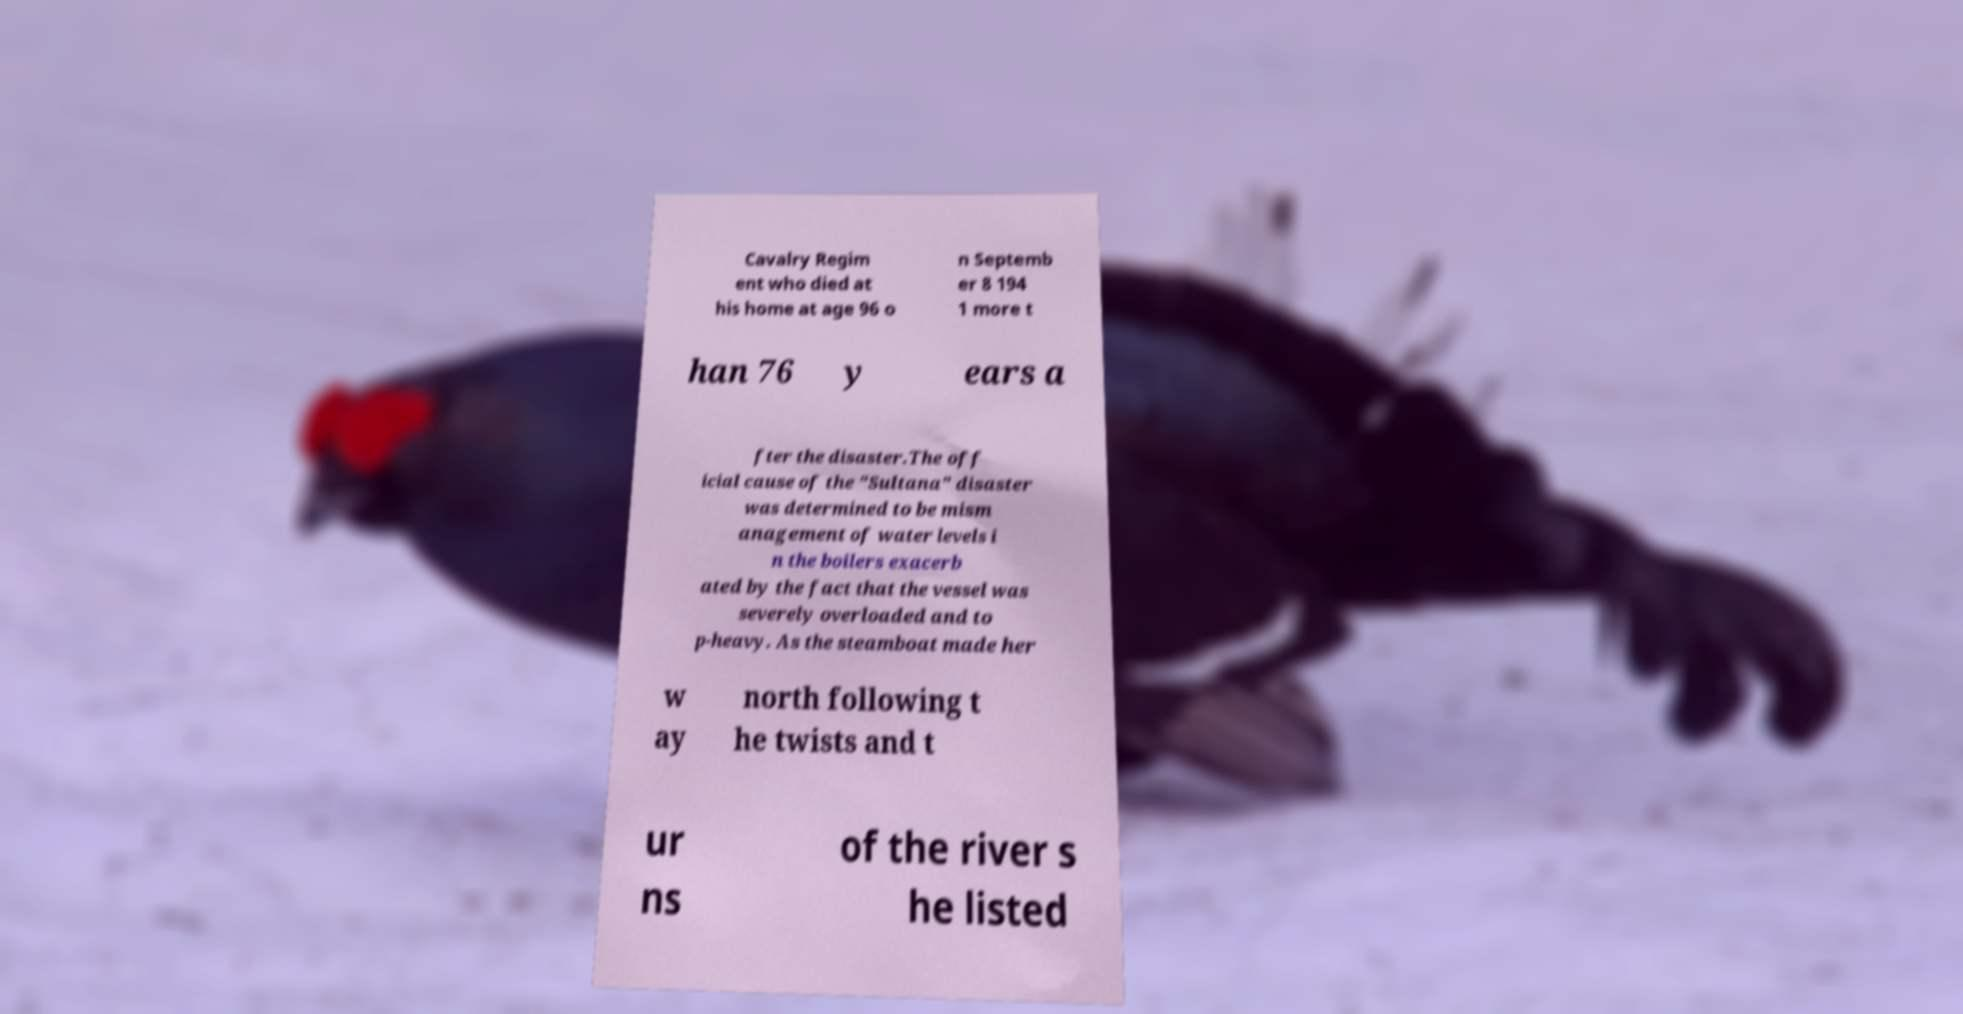Please identify and transcribe the text found in this image. Cavalry Regim ent who died at his home at age 96 o n Septemb er 8 194 1 more t han 76 y ears a fter the disaster.The off icial cause of the "Sultana" disaster was determined to be mism anagement of water levels i n the boilers exacerb ated by the fact that the vessel was severely overloaded and to p-heavy. As the steamboat made her w ay north following t he twists and t ur ns of the river s he listed 